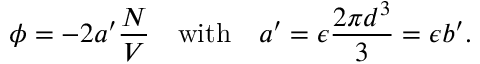<formula> <loc_0><loc_0><loc_500><loc_500>\phi = - 2 a ^ { \prime } { \frac { N } { V } } \quad w i t h \quad a ^ { \prime } = \epsilon { \frac { 2 \pi d ^ { 3 } } { 3 } } = \epsilon b ^ { \prime } .</formula> 